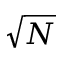<formula> <loc_0><loc_0><loc_500><loc_500>\sqrt { N }</formula> 